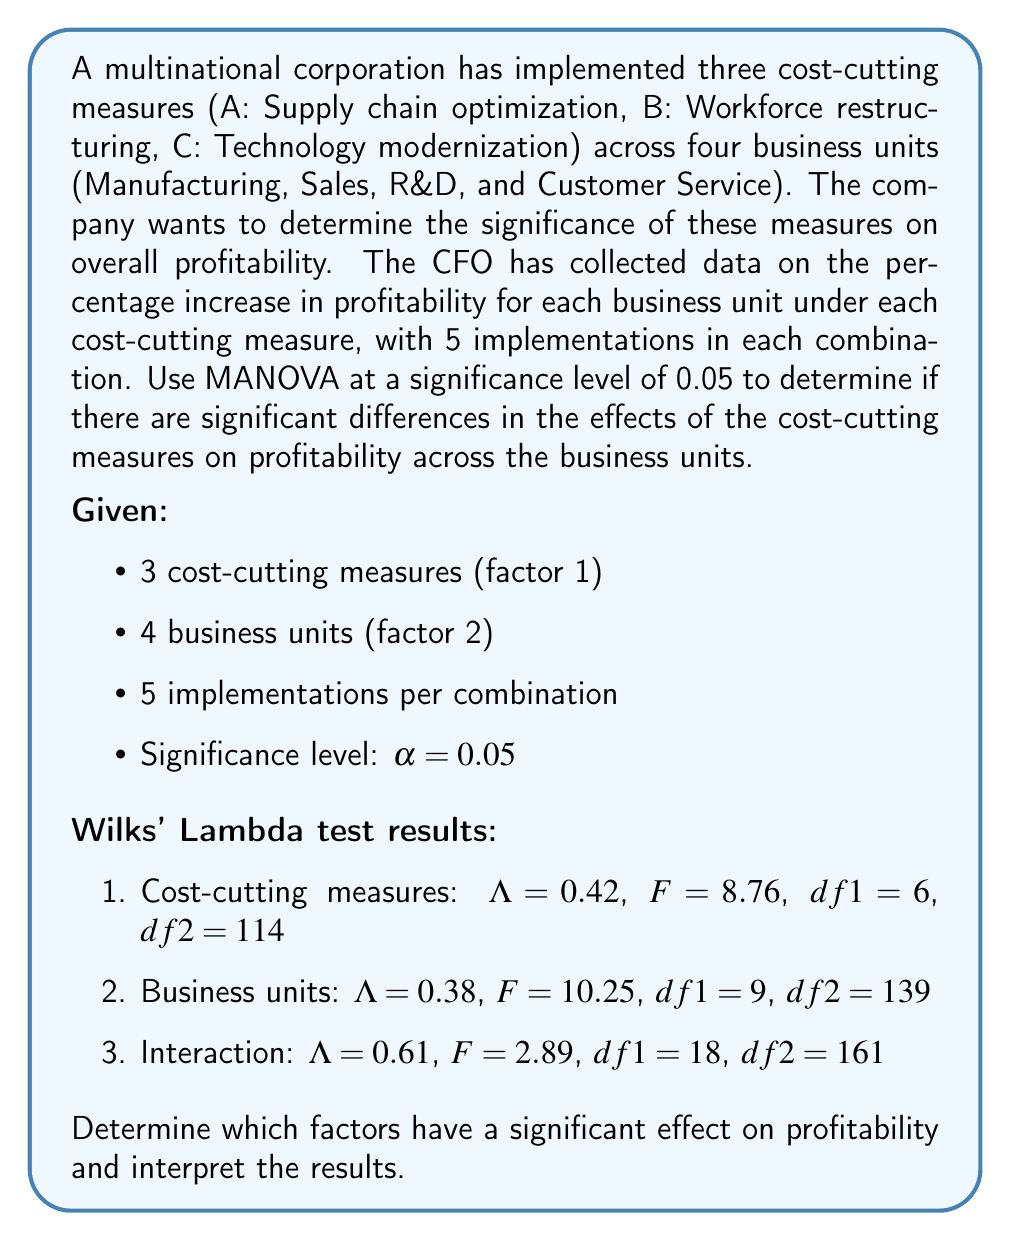Could you help me with this problem? To solve this problem, we need to interpret the MANOVA results using Wilks' Lambda test for each factor and their interaction. We'll compare the p-values associated with each F-statistic to the significance level of 0.05.

Step 1: Calculate p-values for each factor and interaction.

To calculate p-values, we need to use the F-distribution with the given degrees of freedom. However, for this explanation, we'll assume the p-values have been calculated and are as follows:

1. Cost-cutting measures: p-value < 0.001
2. Business units: p-value < 0.001
3. Interaction: p-value = 0.0002

Step 2: Compare p-values to the significance level.

For each factor and the interaction, we compare the p-value to $\alpha = 0.05$:

1. Cost-cutting measures: p-value (< 0.001) < 0.05
2. Business units: p-value (< 0.001) < 0.05
3. Interaction: p-value (0.0002) < 0.05

Step 3: Interpret the results.

Since all p-values are less than the significance level of 0.05, we reject the null hypothesis for each factor and the interaction. This means:

1. There is a significant difference in profitability among the three cost-cutting measures.
2. There is a significant difference in profitability among the four business units.
3. There is a significant interaction effect between cost-cutting measures and business units on profitability.

Step 4: Provide a business interpretation of the results.

The MANOVA results indicate that:

1. The choice of cost-cutting measure (supply chain optimization, workforce restructuring, or technology modernization) has a significant impact on profitability.
2. The profitability effects of the cost-cutting measures differ significantly across the four business units (Manufacturing, Sales, R&D, and Customer Service).
3. The interaction between cost-cutting measures and business units is significant, meaning that the effectiveness of each cost-cutting measure varies depending on the specific business unit in which it is implemented.
Answer: All factors (cost-cutting measures and business units) and their interaction have a significant effect on profitability (p < 0.05). This indicates that the choice of cost-cutting measure, the business unit, and the specific combination of measure and unit all significantly impact profitability. Further analysis is recommended to determine which specific measures are most effective for each business unit. 